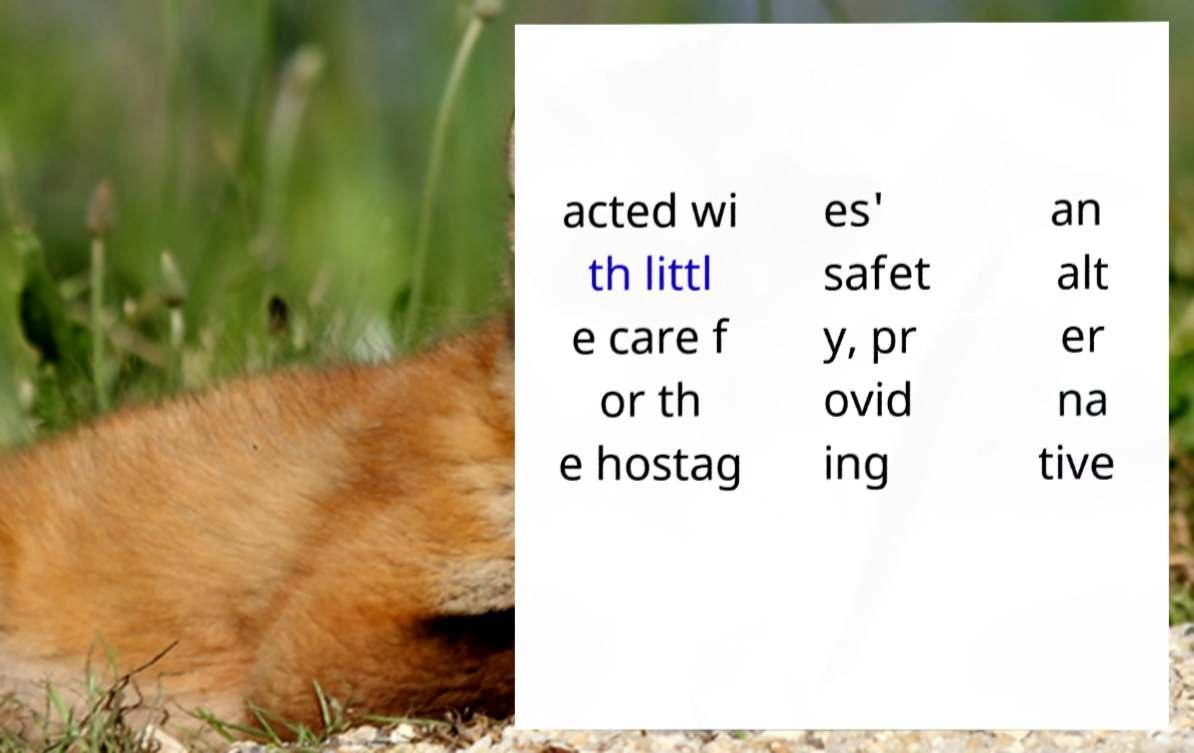Can you accurately transcribe the text from the provided image for me? acted wi th littl e care f or th e hostag es' safet y, pr ovid ing an alt er na tive 